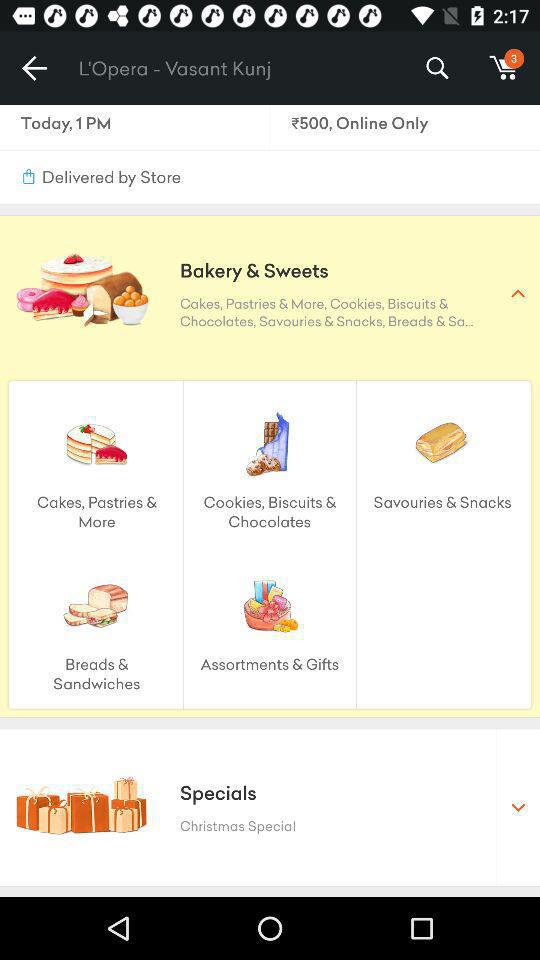What is the location? The location is L'Opera - Vasant Kunj. 